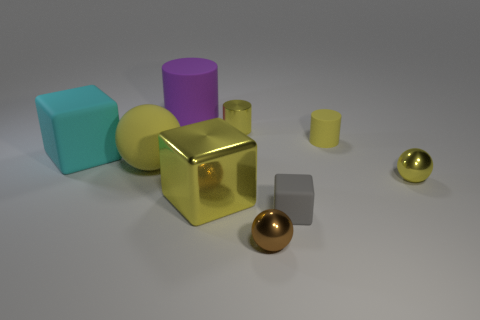Add 1 yellow matte balls. How many objects exist? 10 Subtract all spheres. How many objects are left? 6 Subtract 0 green cylinders. How many objects are left? 9 Subtract all tiny green balls. Subtract all tiny yellow metal spheres. How many objects are left? 8 Add 2 gray things. How many gray things are left? 3 Add 8 shiny spheres. How many shiny spheres exist? 10 